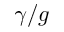<formula> <loc_0><loc_0><loc_500><loc_500>\gamma / g</formula> 